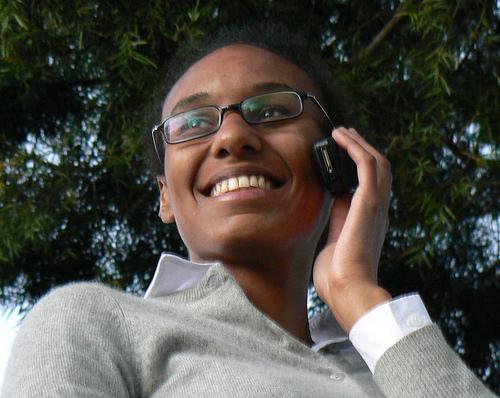Why is she smiling?
Write a very short answer. She's happy. What does the woman have next to the corner of her mouth?
Answer briefly. Phone. Does the girl have glasses?
Quick response, please. Yes. Is the girl sad?
Write a very short answer. No. What is the girl holding?
Short answer required. Phone. 